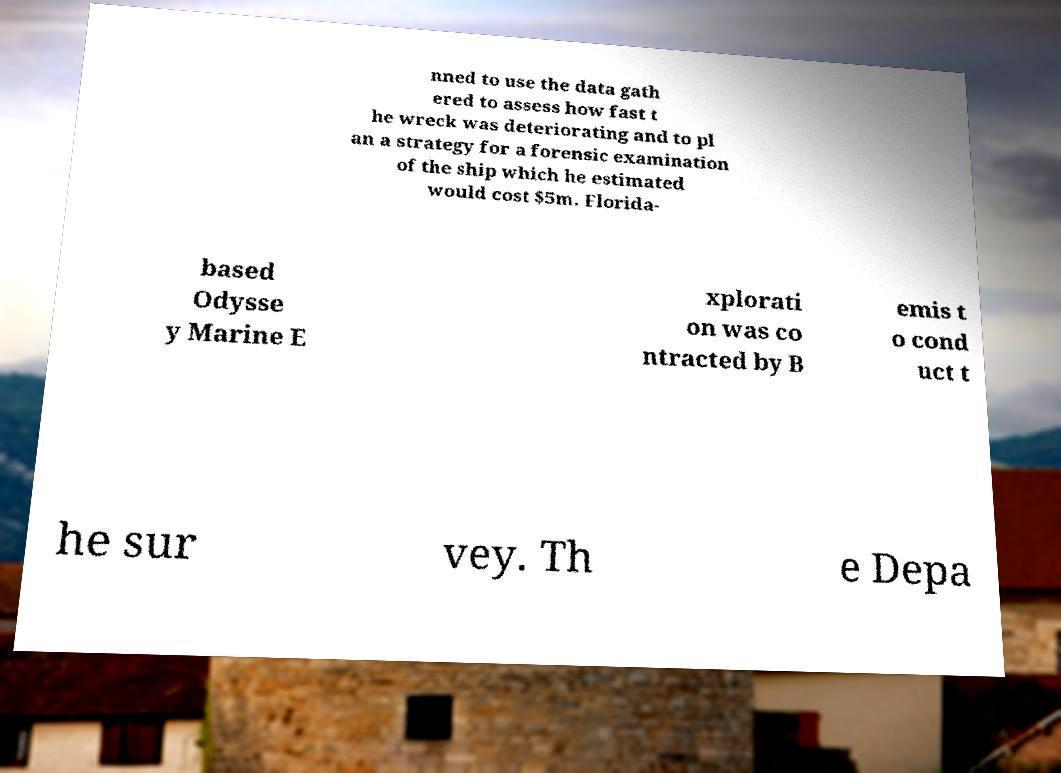Could you assist in decoding the text presented in this image and type it out clearly? nned to use the data gath ered to assess how fast t he wreck was deteriorating and to pl an a strategy for a forensic examination of the ship which he estimated would cost $5m. Florida- based Odysse y Marine E xplorati on was co ntracted by B emis t o cond uct t he sur vey. Th e Depa 